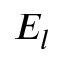<formula> <loc_0><loc_0><loc_500><loc_500>E _ { l }</formula> 